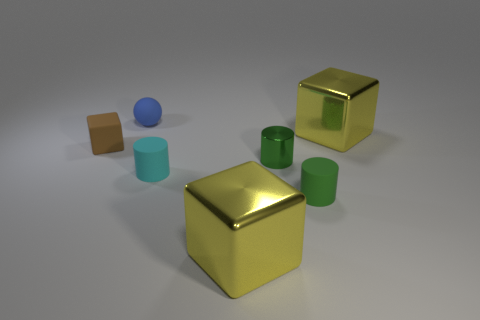How many things are either blocks that are to the right of the brown rubber cube or tiny metallic objects?
Offer a very short reply. 3. There is a big metal object that is behind the metal block that is in front of the cube on the left side of the tiny blue matte object; what shape is it?
Make the answer very short. Cube. What number of yellow things have the same shape as the tiny brown rubber thing?
Your answer should be very brief. 2. What number of yellow shiny cubes are behind the large yellow block that is in front of the tiny matte object in front of the small cyan cylinder?
Give a very brief answer. 1. Are there any cylinders that have the same material as the tiny ball?
Provide a succinct answer. Yes. The other cylinder that is the same color as the metallic cylinder is what size?
Offer a very short reply. Small. Is the number of green cylinders less than the number of large purple metallic things?
Your answer should be very brief. No. There is a tiny matte thing in front of the cyan thing; does it have the same color as the small metal cylinder?
Make the answer very short. Yes. There is a yellow object in front of the tiny green cylinder that is to the left of the tiny rubber cylinder that is on the right side of the green metallic cylinder; what is its material?
Make the answer very short. Metal. Is there a small rubber object of the same color as the sphere?
Offer a terse response. No. 